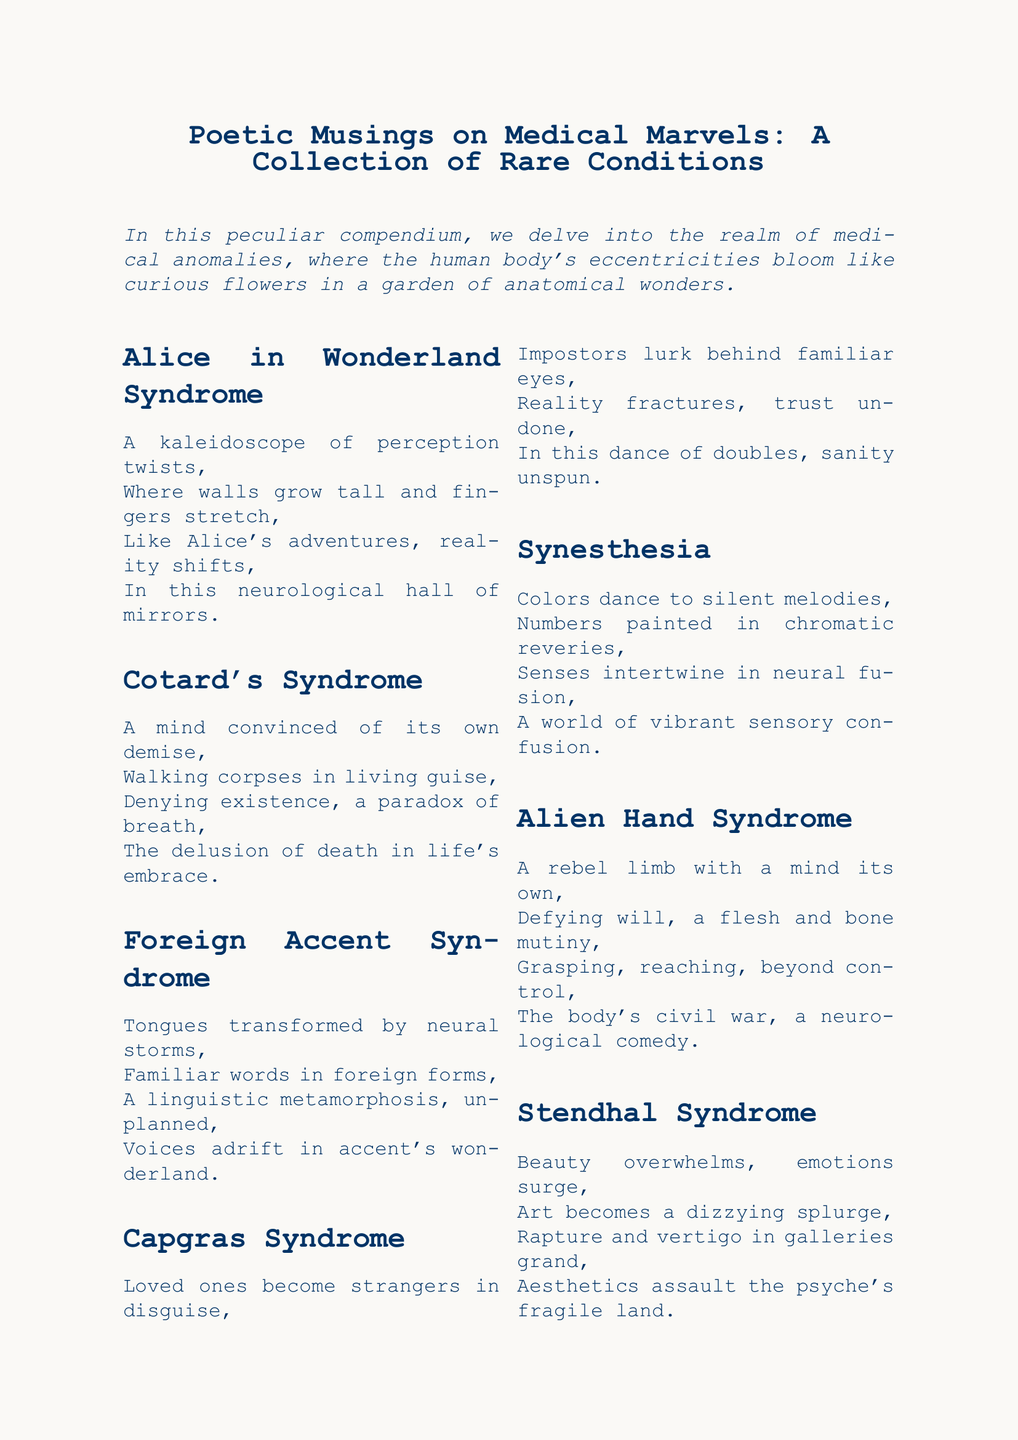What is the title of the document? The title is explicitly stated at the beginning of the document.
Answer: Poetic Musings on Medical Marvels: A Collection of Rare Conditions How many medical conditions are listed in the document? The total number of conditions can be counted from the list provided.
Answer: Eight What syndrome describes a perception where walls grow tall? The description of the syndrome relates directly to the name mentioned.
Answer: Alice in Wonderland Syndrome Which syndrome involves a delusion of death? This syndrome is identified by its defining characteristic described in the text.
Answer: Cotard's Syndrome What unique perspective does Synesthesia provide? The description gives insight into how senses interact in this condition.
Answer: Senses intertwine in neural fusion What occurs in Capgras Syndrome? The document specifies the main phenomenon that characterizes this syndrome.
Answer: Loved ones become strangers in disguise What emotional response does Stendhal Syndrome evoke? The document mentions the specific feeling associated with this syndrome.
Answer: Beauty overwhelms Which condition is characterized by limbs acting independently? The description directly states the phenomenon of the syndrome in question.
Answer: Alien Hand Syndrome 